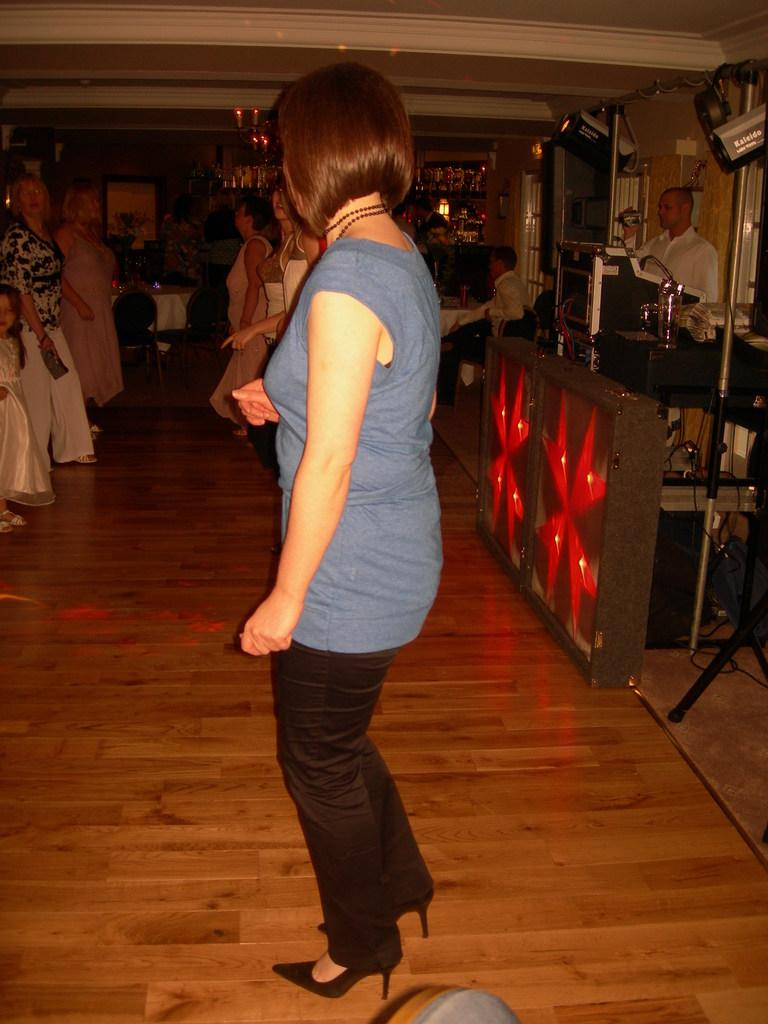What is the main subject of the image? The main subject of the image is a group of people standing. What else can be seen in the image besides the people? There are items on the tables, chairs, and cables visible in the image. Can you describe the objects on the tables? Unfortunately, the provided facts do not specify the items on the tables. What type of objects are present in the image besides the ones mentioned? The facts mention that there are other objects present in the image, but their specific nature is not described. How does the boy in the image help to support the receipt? There is no boy or receipt present in the image. 